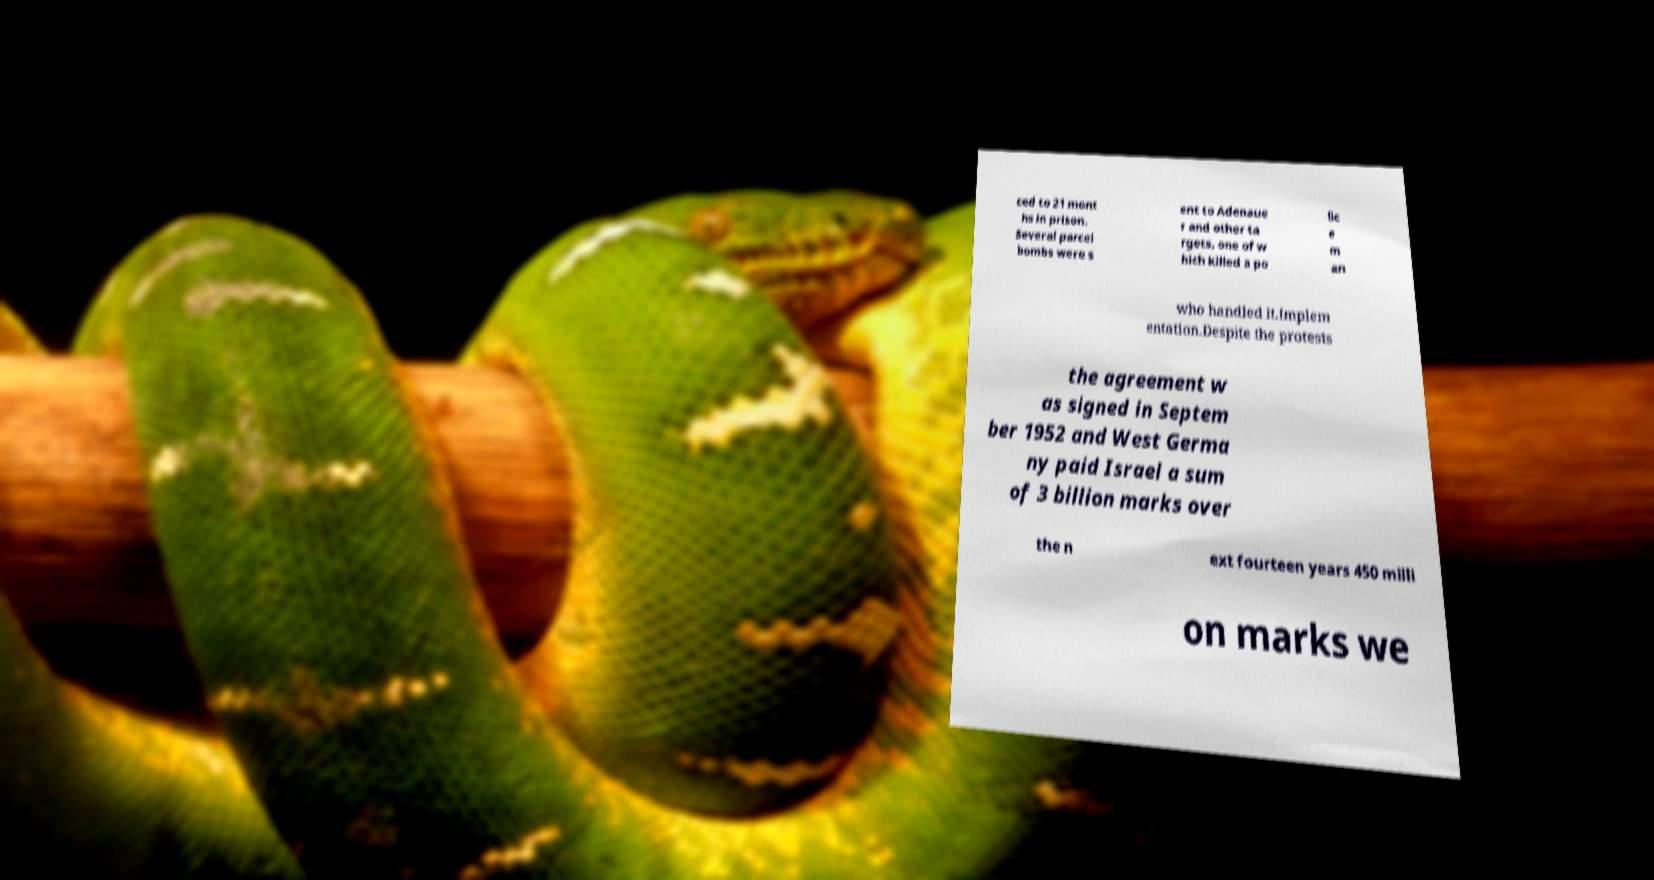Please read and relay the text visible in this image. What does it say? ced to 21 mont hs in prison. Several parcel bombs were s ent to Adenaue r and other ta rgets, one of w hich killed a po lic e m an who handled it.Implem entation.Despite the protests the agreement w as signed in Septem ber 1952 and West Germa ny paid Israel a sum of 3 billion marks over the n ext fourteen years 450 milli on marks we 